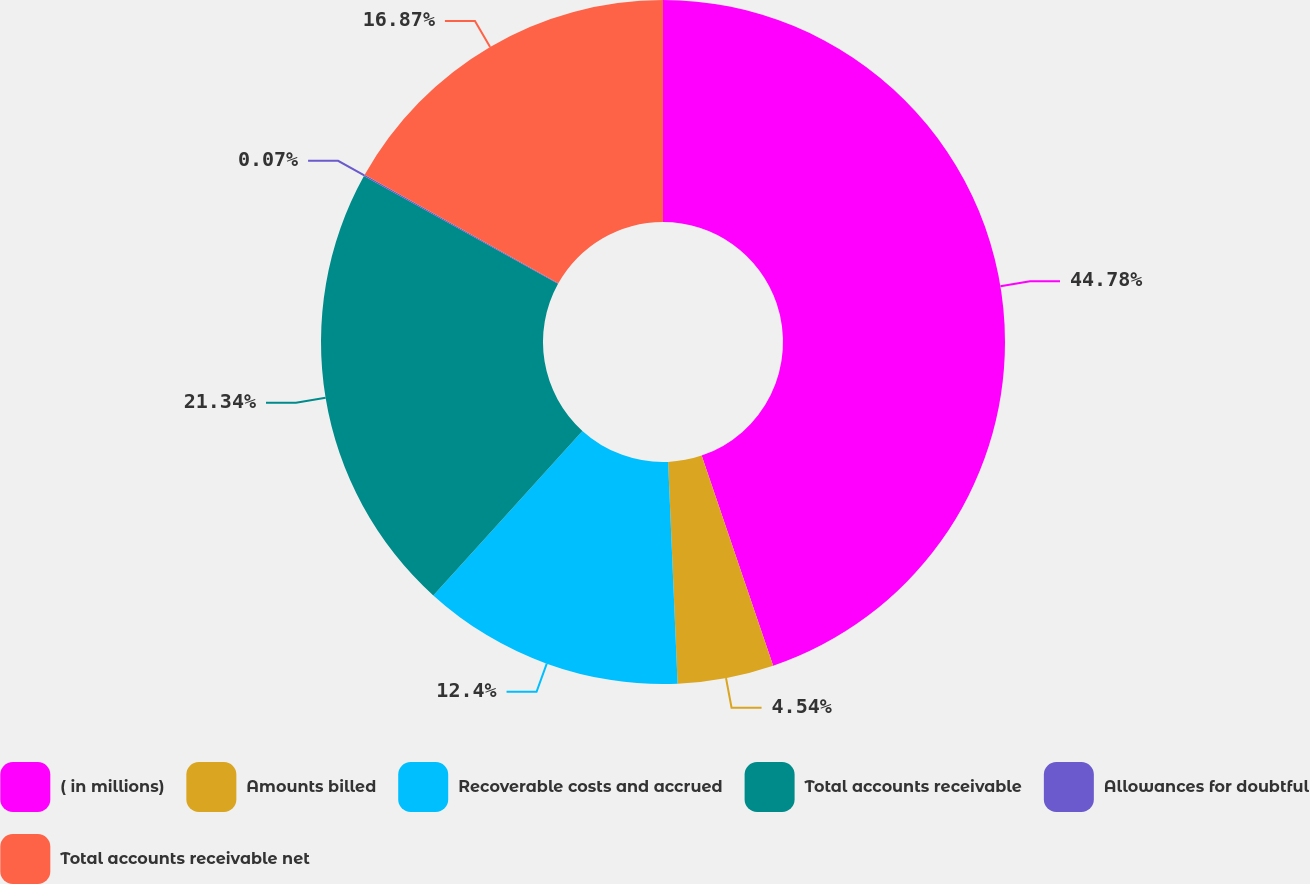Convert chart. <chart><loc_0><loc_0><loc_500><loc_500><pie_chart><fcel>( in millions)<fcel>Amounts billed<fcel>Recoverable costs and accrued<fcel>Total accounts receivable<fcel>Allowances for doubtful<fcel>Total accounts receivable net<nl><fcel>44.78%<fcel>4.54%<fcel>12.4%<fcel>21.34%<fcel>0.07%<fcel>16.87%<nl></chart> 